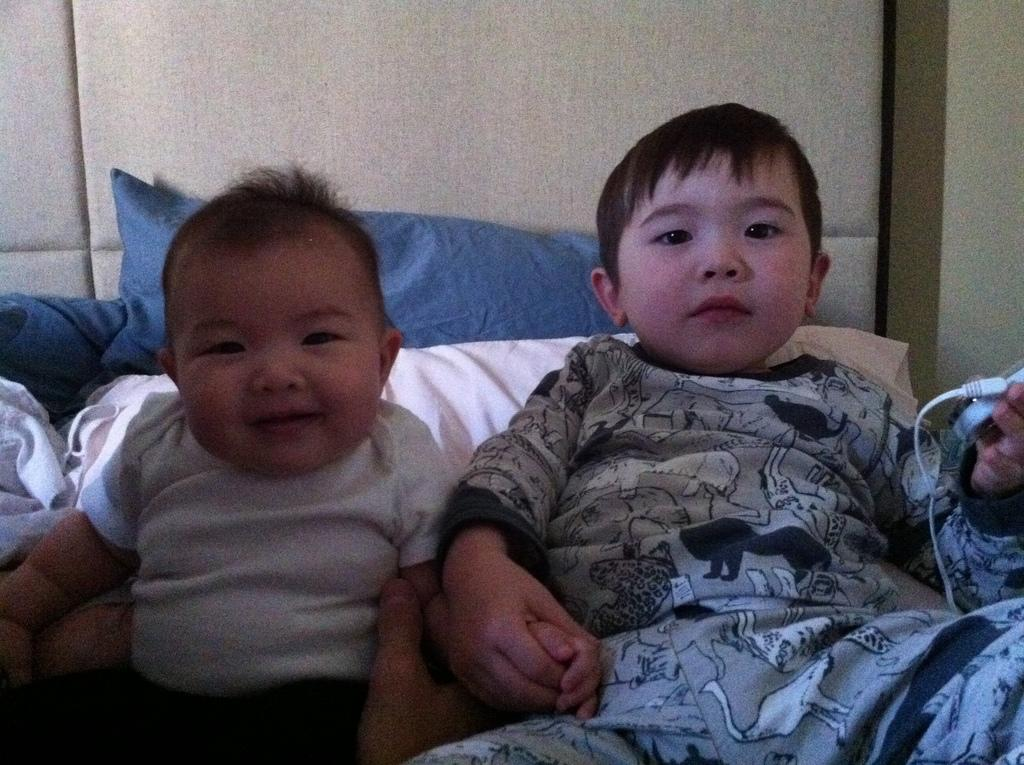How many children are present in the image? There are two children sitting in the image. What is one child holding in the image? One child is holding a wire. What type of soft furnishings can be seen in the image? There are pillows visible in the image. What is a feature of the background in the image? There is a wall in the image. What type of cream is being used by the children in the image? There is no cream present in the image; the children are not using any cream. What type of religious symbol can be seen in the image? There is no religious symbol present in the image. 